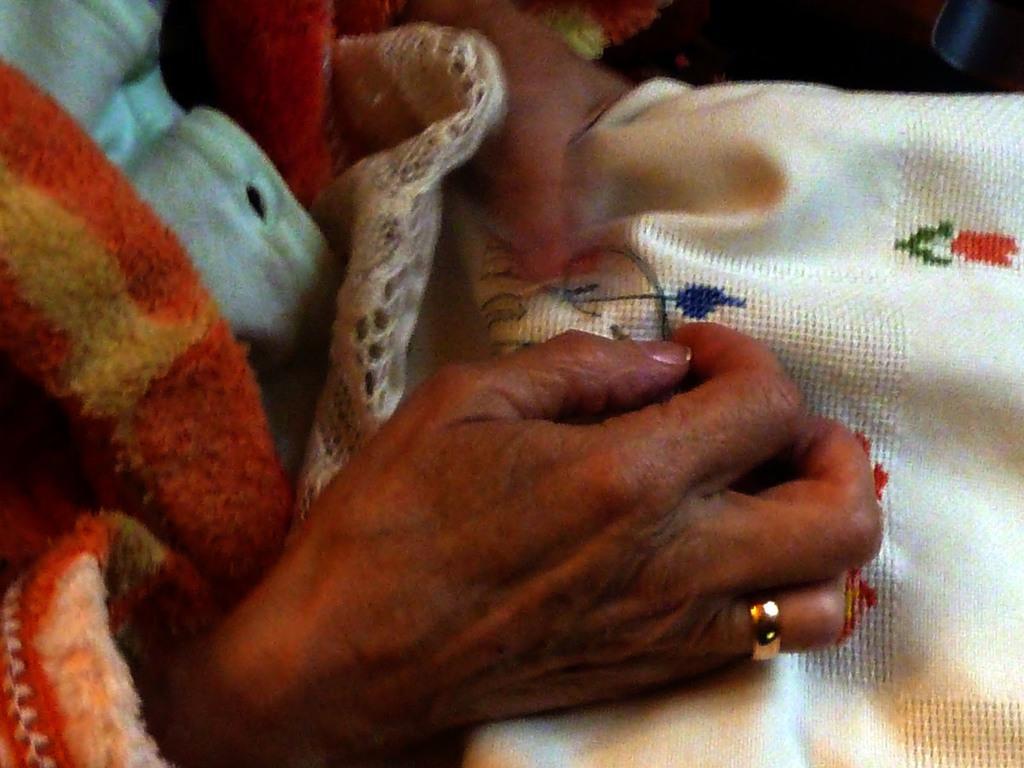Can you describe this image briefly? Here in this picture we can see a person knitting something on the cloth present over there. 